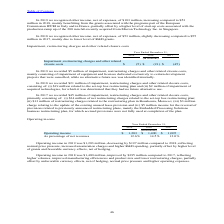According to Stmicroelectronics's financial document, What was the Operating income in 2019? According to the financial document, $1,203 million. The relevant text states: "Operating income in 2019 was $1,203 million, decreasing by $197 million compared to 2018, reflecting normal price pressure, increased unsaturat..." Also, How much did the operating income decrease in 2019 as compared to 2018? According to the financial document, $197 million. The relevant text states: "g income in 2019 was $1,203 million, decreasing by $197 million compared to 2018, reflecting normal price pressure, increased unsaturation charges and higher R&D sp..." Also, What did the improved operating income in 2018 indicate? reflecting higher volumes, improved manufacturing efficiencies and product mix and lower restructuring charges, partially offset by unfavorable currency effects, net of hedging, normal price pressure and higher operating expenses.. The document states: "illion, improved by $395 million compared to 2017, reflecting higher volumes, improved manufacturing efficiencies and product mix and lower restructur..." Also, can you calculate: What is the average Operating income? To answer this question, I need to perform calculations using the financial data. The calculation is: (1,203+1,400+1,005) / 3, which equals 1202.67 (in millions). This is based on the information: "Operating income $ 1,203 $ 1,400 $ 1,005 Operating income $ 1,203 $ 1,400 $ 1,005 Operating income $ 1,203 $ 1,400 $ 1,005..." The key data points involved are: 1,005, 1,203, 1,400. Also, can you calculate: What is the average operating income as percentage of net revenues? To answer this question, I need to perform calculations using the financial data. The calculation is: (12.6+14.5+12.0) / 3, which equals 13.03 (percentage). This is based on the information: "As percentage of net revenues 12.6% 14.5% 12.0% As percentage of net revenues 12.6% 14.5% 12.0% As percentage of net revenues 12.6% 14.5% 12.0%..." The key data points involved are: 12.0, 12.6, 14.5. Also, can you calculate: What is the increase/ (decrease) in Operating income from 2017 to 2019? Based on the calculation: 1,203-1,005, the result is 198 (in millions). This is based on the information: "Operating income $ 1,203 $ 1,400 $ 1,005 Operating income $ 1,203 $ 1,400 $ 1,005..." The key data points involved are: 1,005, 1,203. 